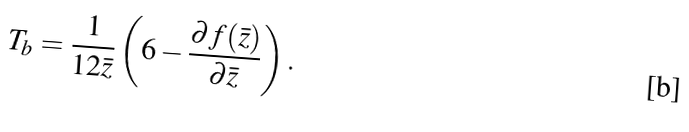<formula> <loc_0><loc_0><loc_500><loc_500>T _ { b } = \frac { 1 } { 1 2 \bar { z } } \left ( 6 - \frac { \partial f ( \bar { z } ) } { \partial \bar { z } } \right ) .</formula> 